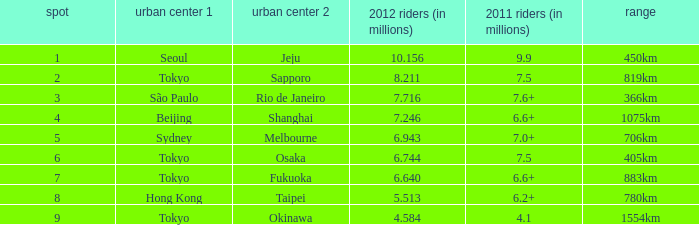How many passengers (in millions) in 2011 flew through along the route that had 6.640 million passengers in 2012? 6.6+. 